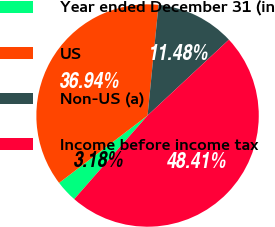Convert chart. <chart><loc_0><loc_0><loc_500><loc_500><pie_chart><fcel>Year ended December 31 (in<fcel>US<fcel>Non-US (a)<fcel>Income before income tax<nl><fcel>3.18%<fcel>36.94%<fcel>11.48%<fcel>48.41%<nl></chart> 